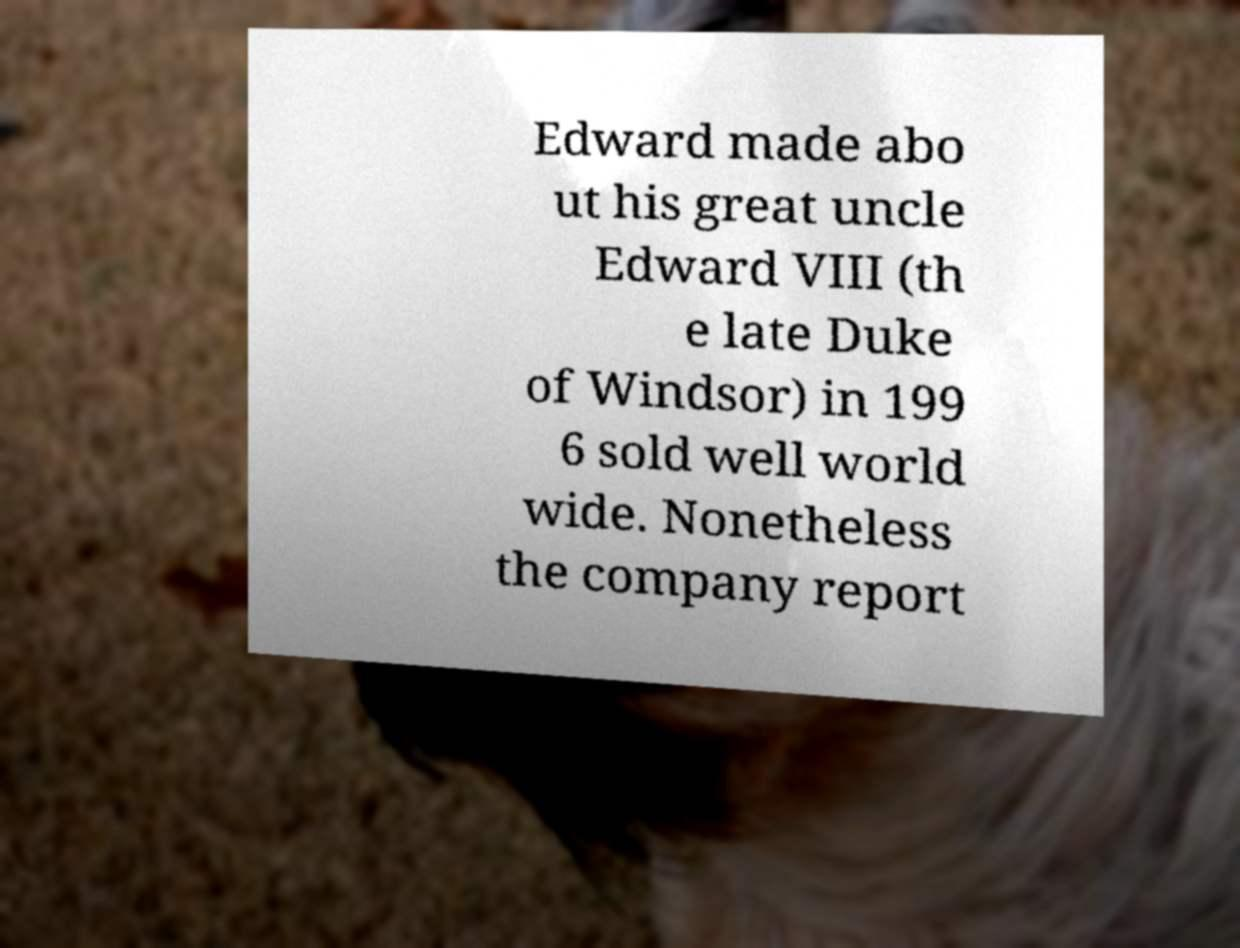For documentation purposes, I need the text within this image transcribed. Could you provide that? Edward made abo ut his great uncle Edward VIII (th e late Duke of Windsor) in 199 6 sold well world wide. Nonetheless the company report 